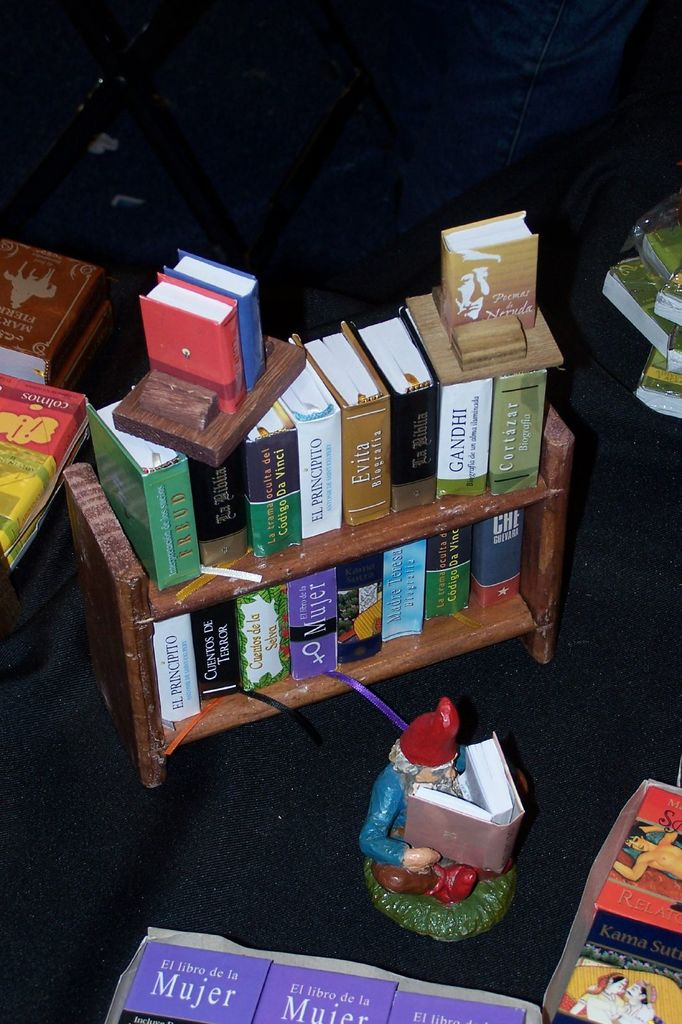Provide a one-sentence caption for the provided image. A whimsical display features an assortment of miniature books, including several copies of 'El Libro de la Mujer' with a purple cover, alongside a figurine of a gnome reading, creatively showcasing literary diversity. 